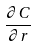Convert formula to latex. <formula><loc_0><loc_0><loc_500><loc_500>\frac { \partial C } { \partial r }</formula> 